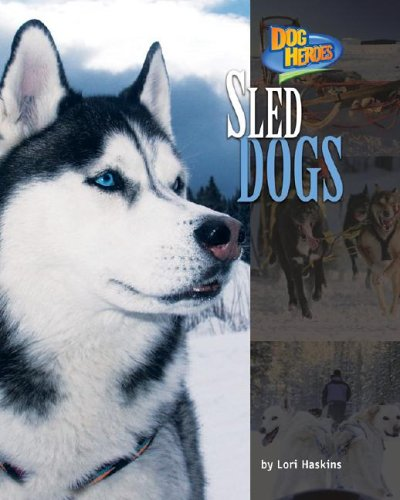Is this a recipe book? No, this is not a recipe book. It is an educational book about sled dogs and their role in outdoor activities and sports. 